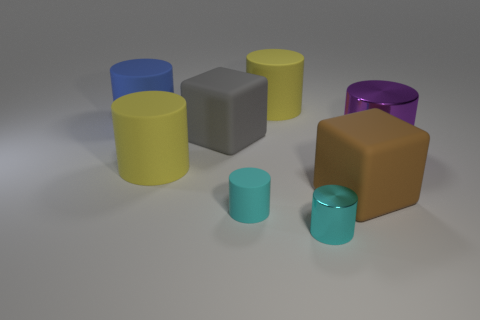Is the size of the shiny cylinder that is to the left of the large purple thing the same as the cyan cylinder that is on the left side of the small metallic cylinder?
Give a very brief answer. Yes. What is the size of the gray block that is made of the same material as the big blue cylinder?
Provide a succinct answer. Large. How many big rubber things are both behind the big gray rubber thing and on the left side of the tiny cyan matte object?
Offer a very short reply. 1. How many things are either large gray metal spheres or yellow cylinders that are behind the blue matte thing?
Your response must be concise. 1. The matte thing that is the same color as the small metal thing is what shape?
Keep it short and to the point. Cylinder. There is a small object left of the cyan metal object; what is its color?
Keep it short and to the point. Cyan. How many things are cylinders behind the brown rubber thing or cyan objects?
Your answer should be compact. 6. There is another rubber cube that is the same size as the brown matte cube; what color is it?
Your answer should be compact. Gray. Is the number of cyan metallic cylinders on the left side of the brown rubber cube greater than the number of small green blocks?
Make the answer very short. Yes. What is the material of the cylinder that is both on the right side of the tiny matte cylinder and in front of the purple thing?
Offer a very short reply. Metal. 